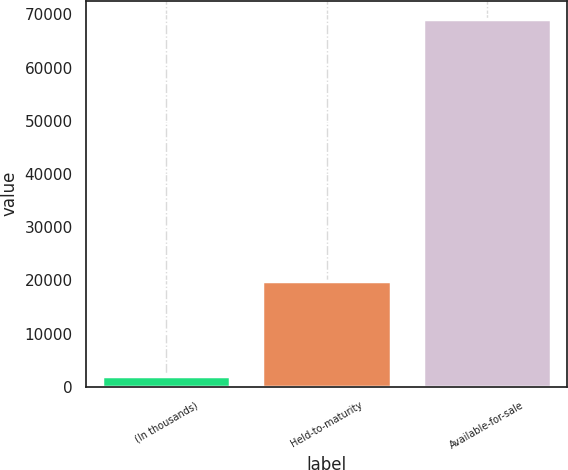Convert chart to OTSL. <chart><loc_0><loc_0><loc_500><loc_500><bar_chart><fcel>(In thousands)<fcel>Held-to-maturity<fcel>Available-for-sale<nl><fcel>2013<fcel>19905<fcel>69106<nl></chart> 